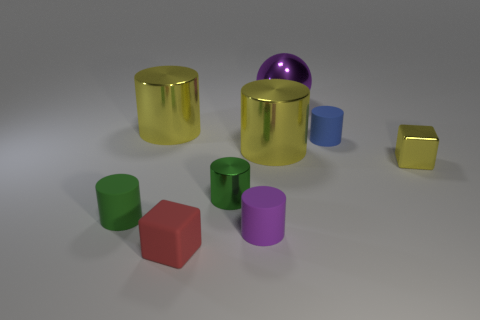Subtract 1 cylinders. How many cylinders are left? 5 Subtract all tiny metal cylinders. How many cylinders are left? 5 Subtract all purple cubes. How many green cylinders are left? 2 Subtract all purple cylinders. How many cylinders are left? 5 Subtract all purple cylinders. Subtract all gray balls. How many cylinders are left? 5 Subtract 0 purple blocks. How many objects are left? 9 Subtract all cylinders. How many objects are left? 3 Subtract all yellow cubes. Subtract all metal spheres. How many objects are left? 7 Add 3 large yellow shiny things. How many large yellow shiny things are left? 5 Add 6 purple rubber things. How many purple rubber things exist? 7 